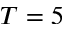Convert formula to latex. <formula><loc_0><loc_0><loc_500><loc_500>T = 5</formula> 